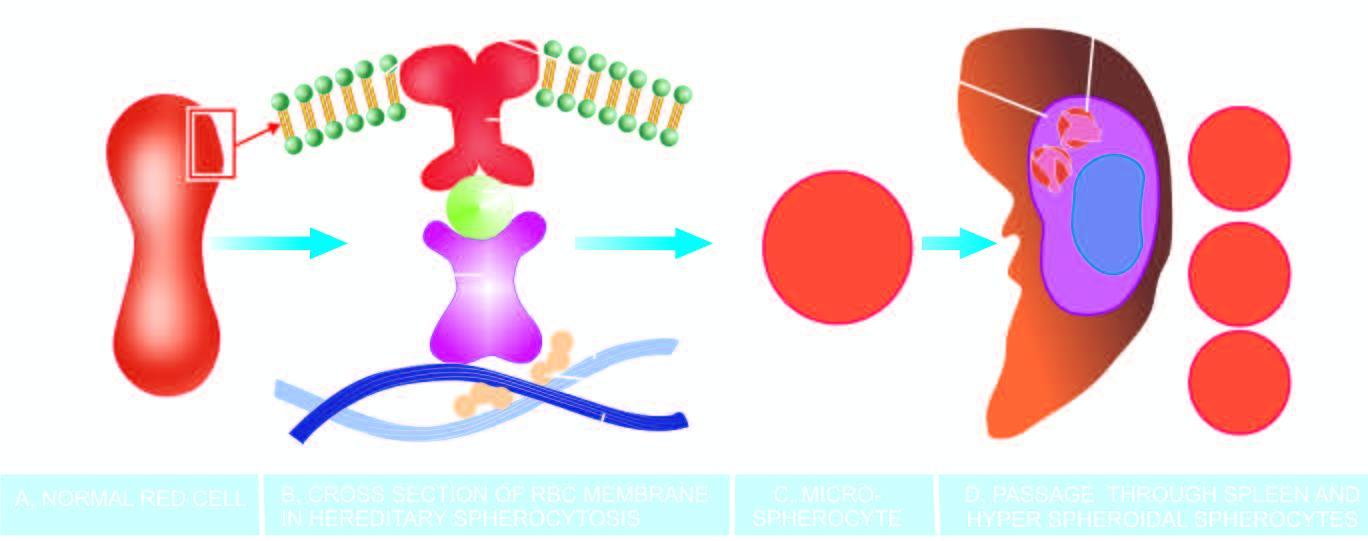do m phase lose their cell membrane further during passage through the spleen?
Answer the question using a single word or phrase. No 